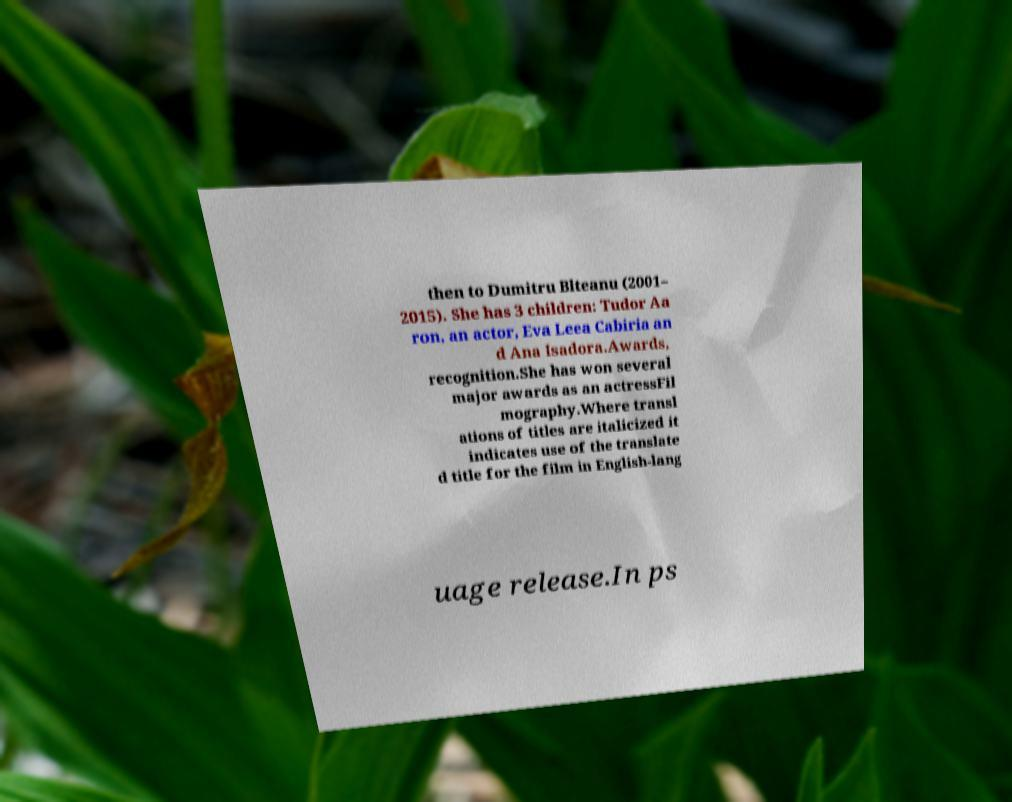I need the written content from this picture converted into text. Can you do that? then to Dumitru Blteanu (2001– 2015). She has 3 children: Tudor Aa ron, an actor, Eva Leea Cabiria an d Ana Isadora.Awards, recognition.She has won several major awards as an actressFil mography.Where transl ations of titles are italicized it indicates use of the translate d title for the film in English-lang uage release.In ps 